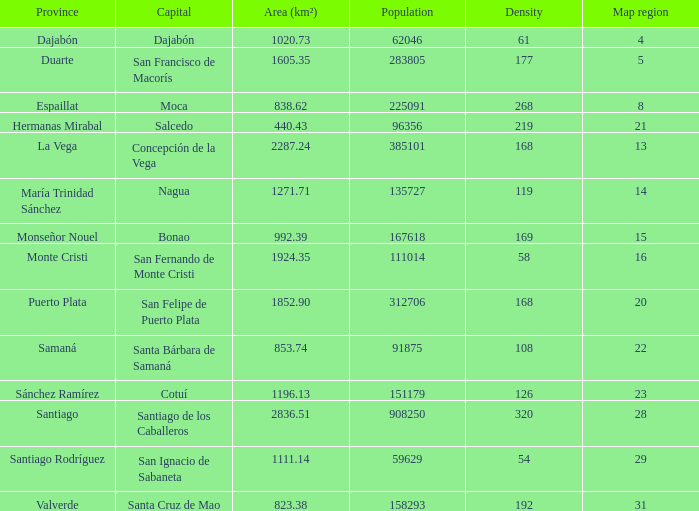How many capitals are there when area (km²) is 1111.14? 1.0. Can you give me this table as a dict? {'header': ['Province', 'Capital', 'Area (km²)', 'Population', 'Density', 'Map region'], 'rows': [['Dajabón', 'Dajabón', '1020.73', '62046', '61', '4'], ['Duarte', 'San Francisco de Macorís', '1605.35', '283805', '177', '5'], ['Espaillat', 'Moca', '838.62', '225091', '268', '8'], ['Hermanas Mirabal', 'Salcedo', '440.43', '96356', '219', '21'], ['La Vega', 'Concepción de la Vega', '2287.24', '385101', '168', '13'], ['María Trinidad Sánchez', 'Nagua', '1271.71', '135727', '119', '14'], ['Monseñor Nouel', 'Bonao', '992.39', '167618', '169', '15'], ['Monte Cristi', 'San Fernando de Monte Cristi', '1924.35', '111014', '58', '16'], ['Puerto Plata', 'San Felipe de Puerto Plata', '1852.90', '312706', '168', '20'], ['Samaná', 'Santa Bárbara de Samaná', '853.74', '91875', '108', '22'], ['Sánchez Ramírez', 'Cotuí', '1196.13', '151179', '126', '23'], ['Santiago', 'Santiago de los Caballeros', '2836.51', '908250', '320', '28'], ['Santiago Rodríguez', 'San Ignacio de Sabaneta', '1111.14', '59629', '54', '29'], ['Valverde', 'Santa Cruz de Mao', '823.38', '158293', '192', '31']]} 